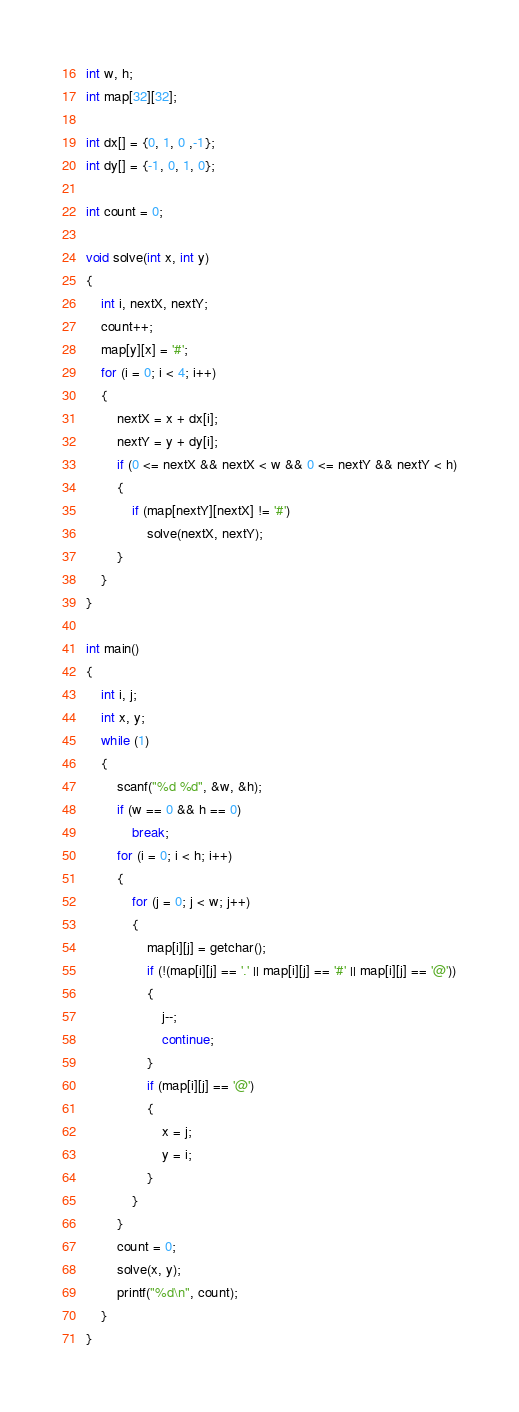<code> <loc_0><loc_0><loc_500><loc_500><_C_>int w, h;
int map[32][32];

int dx[] = {0, 1, 0 ,-1};
int dy[] = {-1, 0, 1, 0};

int count = 0;

void solve(int x, int y)
{
    int i, nextX, nextY;
    count++;
    map[y][x] = '#';
    for (i = 0; i < 4; i++)
    {
        nextX = x + dx[i];
        nextY = y + dy[i];
        if (0 <= nextX && nextX < w && 0 <= nextY && nextY < h)
        {
            if (map[nextY][nextX] != '#')
                solve(nextX, nextY);
        }
    }
}

int main()
{
    int i, j;
    int x, y;
    while (1)
    {
        scanf("%d %d", &w, &h);
        if (w == 0 && h == 0)
            break;
        for (i = 0; i < h; i++)
        {
            for (j = 0; j < w; j++)
            {
                map[i][j] = getchar();
                if (!(map[i][j] == '.' || map[i][j] == '#' || map[i][j] == '@'))
                {
                    j--;
                    continue;
                }
                if (map[i][j] == '@')
                {
                    x = j;
                    y = i;
                }
            }
        }
        count = 0;
        solve(x, y);
        printf("%d\n", count);
    }
}</code> 